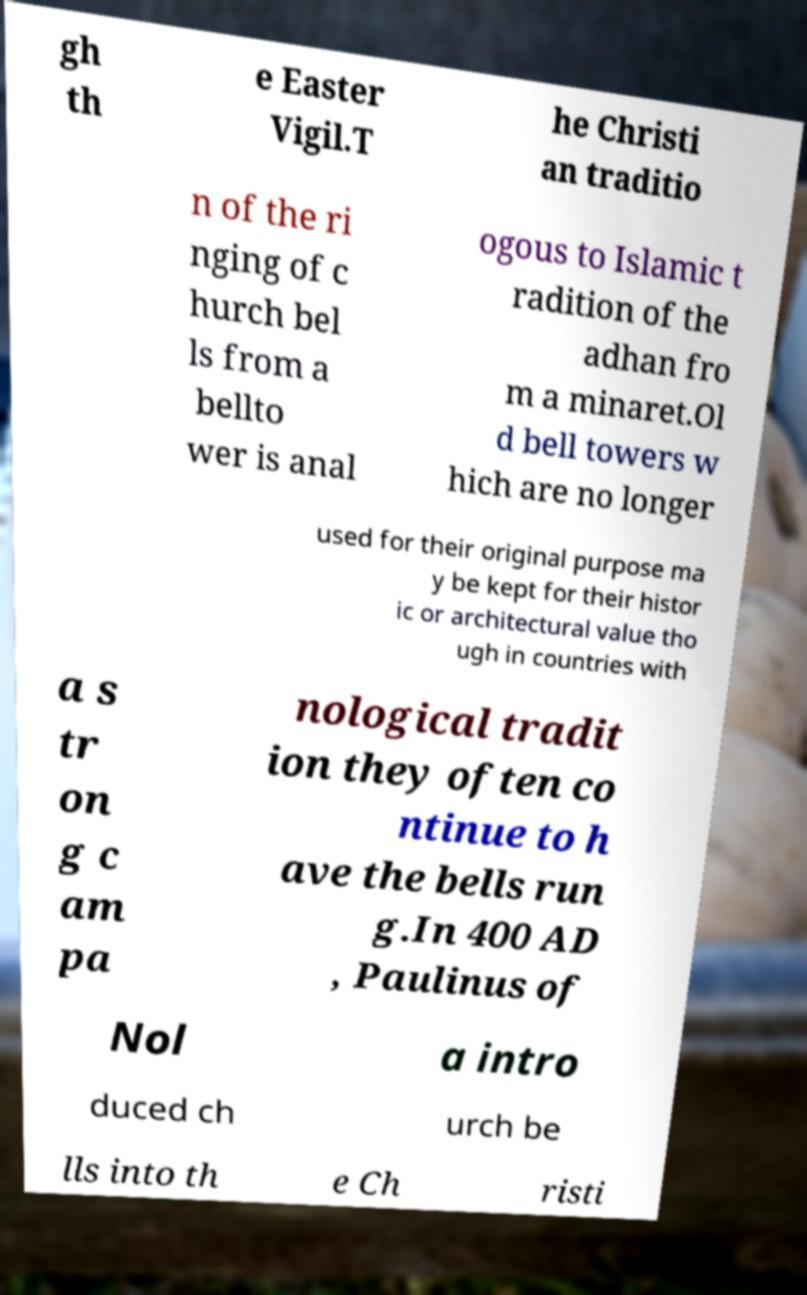There's text embedded in this image that I need extracted. Can you transcribe it verbatim? gh th e Easter Vigil.T he Christi an traditio n of the ri nging of c hurch bel ls from a bellto wer is anal ogous to Islamic t radition of the adhan fro m a minaret.Ol d bell towers w hich are no longer used for their original purpose ma y be kept for their histor ic or architectural value tho ugh in countries with a s tr on g c am pa nological tradit ion they often co ntinue to h ave the bells run g.In 400 AD , Paulinus of Nol a intro duced ch urch be lls into th e Ch risti 